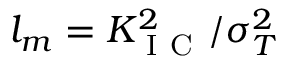Convert formula to latex. <formula><loc_0><loc_0><loc_500><loc_500>l _ { m } = K _ { I C } ^ { 2 } / \sigma _ { T } ^ { 2 }</formula> 